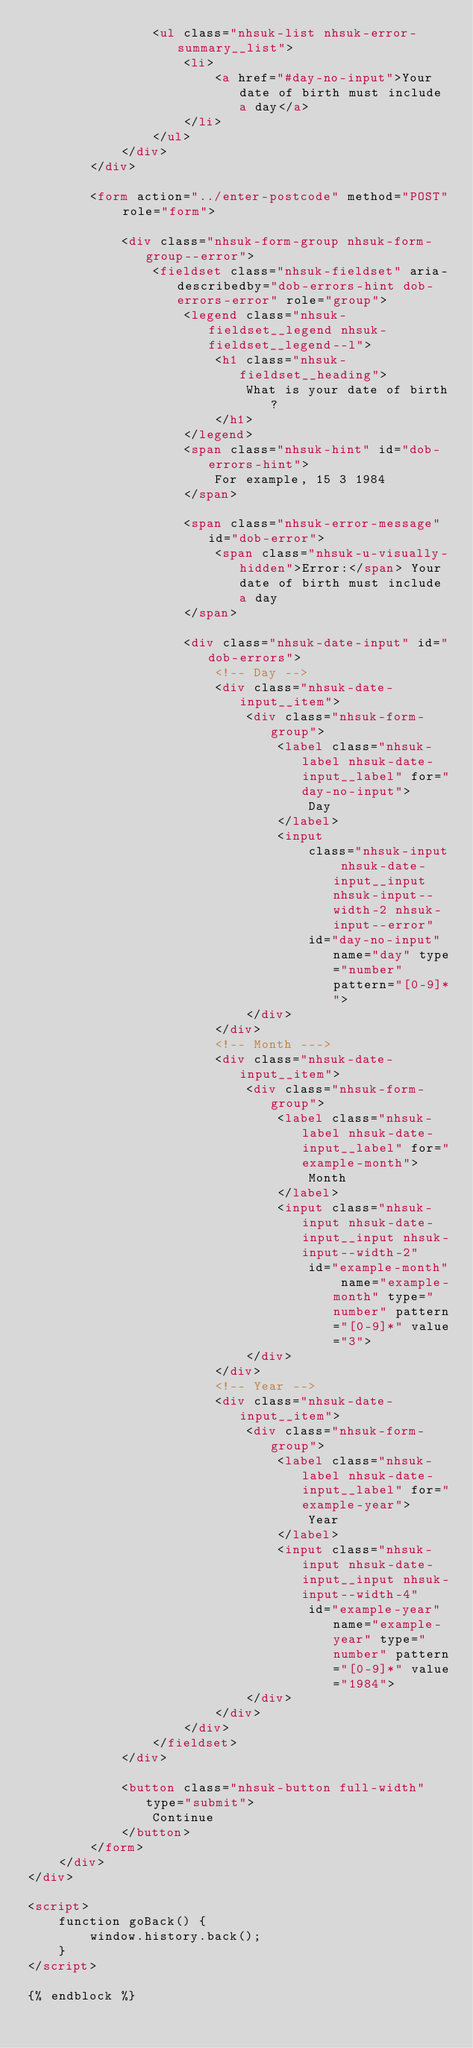<code> <loc_0><loc_0><loc_500><loc_500><_HTML_>                <ul class="nhsuk-list nhsuk-error-summary__list">
                    <li>
                        <a href="#day-no-input">Your date of birth must include a day</a>
                    </li>
                </ul>
            </div>
        </div>

        <form action="../enter-postcode" method="POST" role="form">

            <div class="nhsuk-form-group nhsuk-form-group--error">
                <fieldset class="nhsuk-fieldset" aria-describedby="dob-errors-hint dob-errors-error" role="group">
                    <legend class="nhsuk-fieldset__legend nhsuk-fieldset__legend--l">
                        <h1 class="nhsuk-fieldset__heading">
                            What is your date of birth?
                        </h1>
                    </legend>
                    <span class="nhsuk-hint" id="dob-errors-hint">
                        For example, 15 3 1984
                    </span>

                    <span class="nhsuk-error-message" id="dob-error">
                        <span class="nhsuk-u-visually-hidden">Error:</span> Your date of birth must include a day
                    </span>

                    <div class="nhsuk-date-input" id="dob-errors">
                        <!-- Day -->
                        <div class="nhsuk-date-input__item">
                            <div class="nhsuk-form-group">
                                <label class="nhsuk-label nhsuk-date-input__label" for="day-no-input">
                                    Day
                                </label>
                                <input
                                    class="nhsuk-input nhsuk-date-input__input nhsuk-input--width-2 nhsuk-input--error"
                                    id="day-no-input" name="day" type="number" pattern="[0-9]*">
                            </div>
                        </div>
                        <!-- Month --->
                        <div class="nhsuk-date-input__item">
                            <div class="nhsuk-form-group">
                                <label class="nhsuk-label nhsuk-date-input__label" for="example-month">
                                    Month
                                </label>
                                <input class="nhsuk-input nhsuk-date-input__input nhsuk-input--width-2"
                                    id="example-month" name="example-month" type="number" pattern="[0-9]*" value="3">
                            </div>
                        </div>
                        <!-- Year -->
                        <div class="nhsuk-date-input__item">
                            <div class="nhsuk-form-group">
                                <label class="nhsuk-label nhsuk-date-input__label" for="example-year">
                                    Year
                                </label>
                                <input class="nhsuk-input nhsuk-date-input__input nhsuk-input--width-4"
                                    id="example-year" name="example-year" type="number" pattern="[0-9]*" value="1984">
                            </div>
                        </div>
                    </div>
                </fieldset>
            </div>

            <button class="nhsuk-button full-width" type="submit">
                Continue
            </button>
        </form>
    </div>
</div>

<script>
    function goBack() {
        window.history.back();
    }
</script>

{% endblock %}</code> 